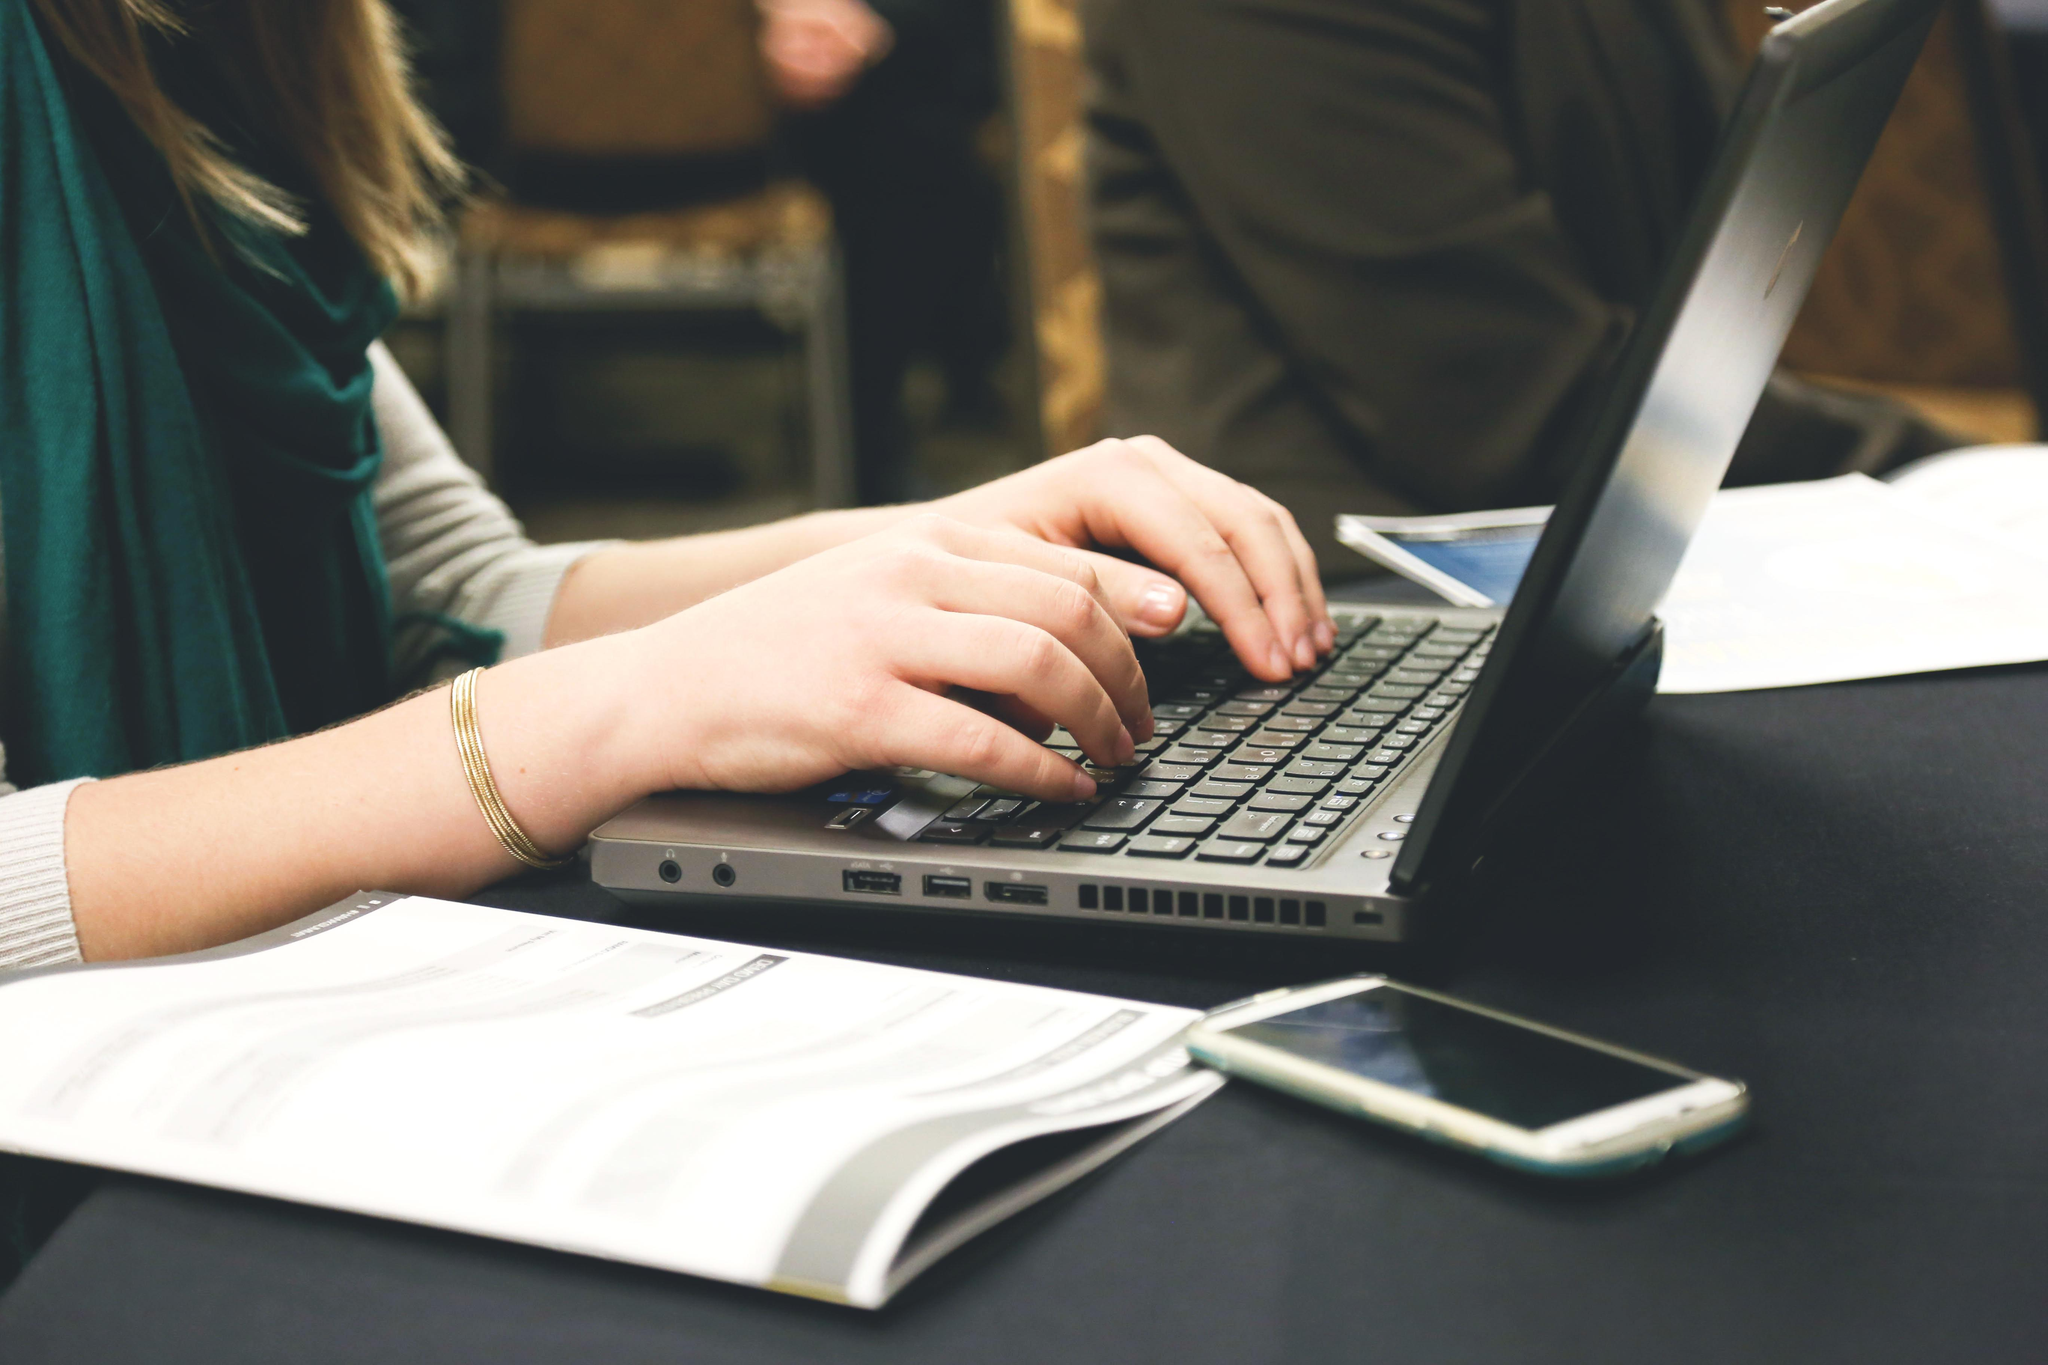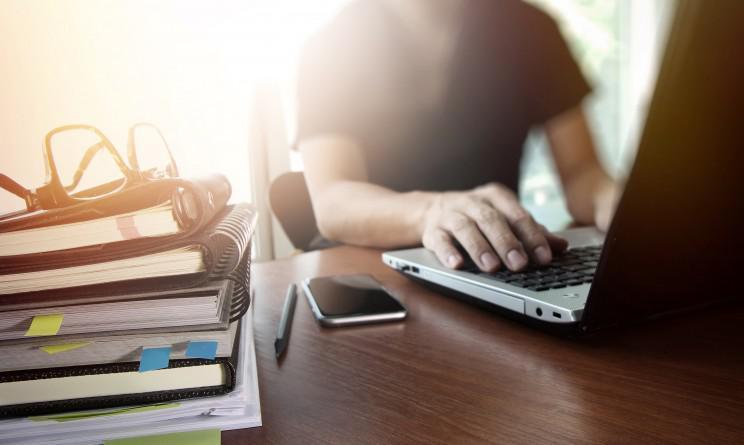The first image is the image on the left, the second image is the image on the right. Evaluate the accuracy of this statement regarding the images: "A pen is on a paper near a laptop in at least one of the images.". Is it true? Answer yes or no. No. The first image is the image on the left, the second image is the image on the right. For the images displayed, is the sentence "Each image shows at least one hand on the keyboard of a laptop with its open screen facing leftward." factually correct? Answer yes or no. Yes. 